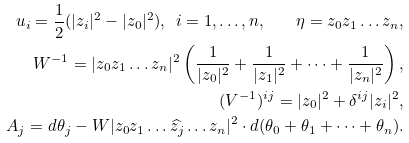<formula> <loc_0><loc_0><loc_500><loc_500>u _ { i } = \frac { 1 } { 2 } ( | z _ { i } | ^ { 2 } - | z _ { 0 } | ^ { 2 } ) , \ i = 1 , \dots , n , \quad \eta = z _ { 0 } z _ { 1 } \dots z _ { n } , \\ W ^ { - 1 } = | z _ { 0 } z _ { 1 } \dots z _ { n } | ^ { 2 } \left ( \frac { 1 } { | z _ { 0 } | ^ { 2 } } + \frac { 1 } { | z _ { 1 } | ^ { 2 } } + \dots + \frac { 1 } { | z _ { n } | ^ { 2 } } \right ) , \\ ( V ^ { - 1 } ) ^ { i j } = | z _ { 0 } | ^ { 2 } + \delta ^ { i j } | z _ { i } | ^ { 2 } , \\ A _ { j } = d \theta _ { j } - W | z _ { 0 } z _ { 1 } \dots \widehat { z _ { j } } \dots z _ { n } | ^ { 2 } \cdot d ( \theta _ { 0 } + \theta _ { 1 } + \dots + \theta _ { n } ) .</formula> 